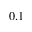<formula> <loc_0><loc_0><loc_500><loc_500>0 . 1</formula> 